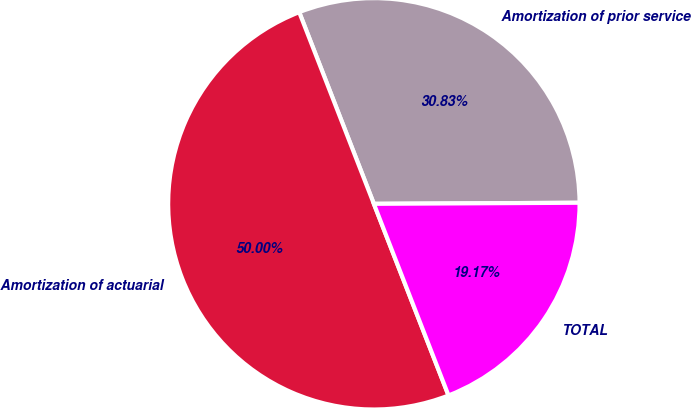<chart> <loc_0><loc_0><loc_500><loc_500><pie_chart><fcel>Amortization of prior service<fcel>Amortization of actuarial<fcel>TOTAL<nl><fcel>30.83%<fcel>50.0%<fcel>19.17%<nl></chart> 